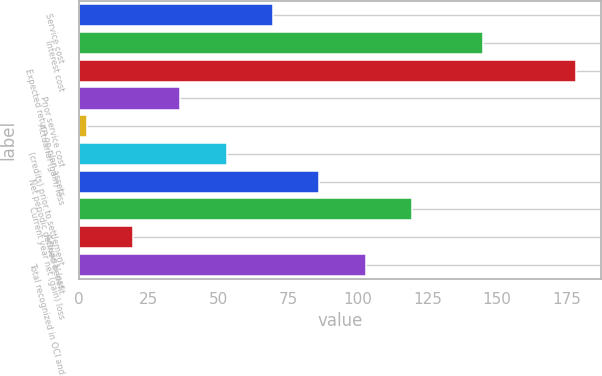Convert chart. <chart><loc_0><loc_0><loc_500><loc_500><bar_chart><fcel>Service cost<fcel>Interest cost<fcel>Expected return on plan assets<fcel>Prior service cost<fcel>Actuarial (gain) loss<fcel>(credits) prior to settlement<fcel>Net periodic defined benefit<fcel>Current year net (gain) loss<fcel>Actuarial loss<fcel>Total recognized in OCI and<nl><fcel>69.6<fcel>145<fcel>178.2<fcel>36.2<fcel>3<fcel>53<fcel>86.2<fcel>119.4<fcel>19.6<fcel>102.8<nl></chart> 